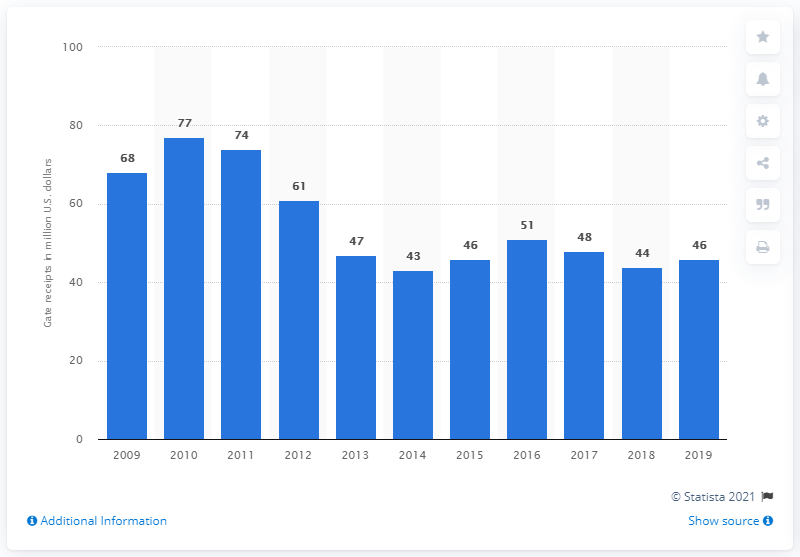Draw attention to some important aspects in this diagram. The gate receipts of the Chicago White Sox in 2019 were approximately $46 million. 